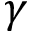<formula> <loc_0><loc_0><loc_500><loc_500>\gamma</formula> 